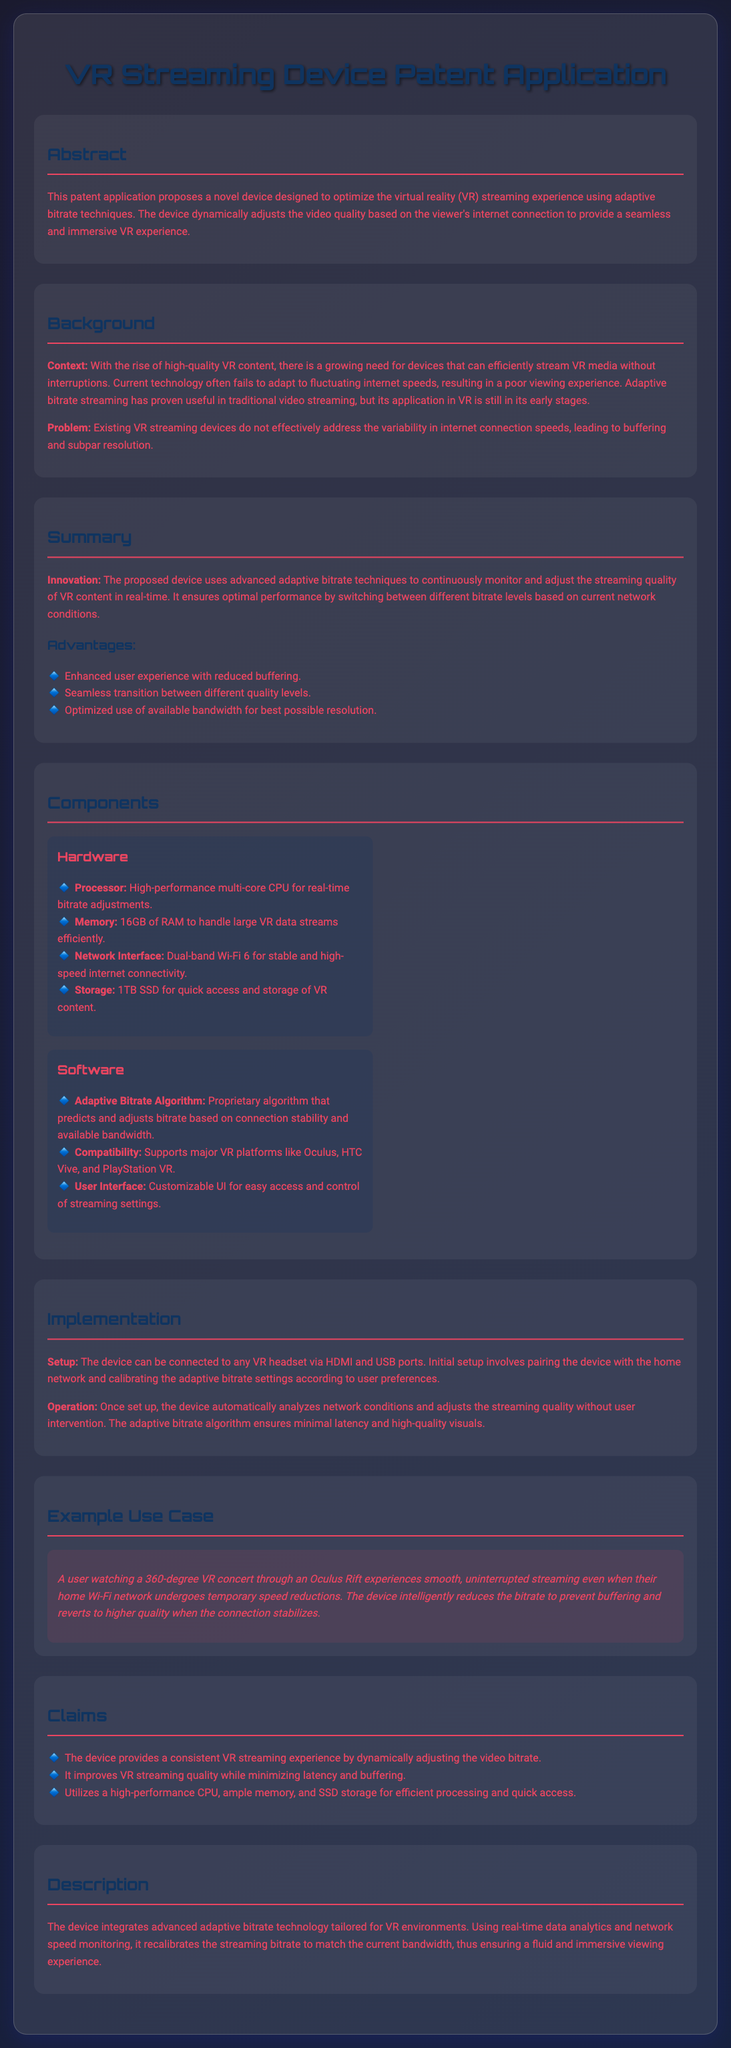What is the main purpose of the device? The main purpose of the device is to optimize the virtual reality (VR) streaming experience using adaptive bitrate techniques.
Answer: Optimize VR streaming experience What is the processor type mentioned? The document specifies a high-performance multi-core CPU for real-time bitrate adjustments.
Answer: High-performance multi-core CPU How much RAM does the device have? The device is stated to have 16GB of RAM to handle large VR data streams efficiently.
Answer: 16GB What is a major disadvantage of current VR streaming technology? The major disadvantage is that existing devices do not effectively address the variability in internet connection speeds.
Answer: Variability in internet connection speeds Which platforms does the software support? The software supports major VR platforms like Oculus, HTC Vive, and PlayStation VR.
Answer: Oculus, HTC Vive, PlayStation VR What happens when the home Wi-Fi network undergoes speed reductions? The device intelligently reduces the bitrate to prevent buffering.
Answer: Reduces the bitrate What is the total storage capacity of the device? The document mentions that the device has a storage capacity of 1TB SSD.
Answer: 1TB SSD How does the adaptive bitrate algorithm function? The algorithm predicts and adjusts bitrate based on connection stability and available bandwidth.
Answer: Predicts and adjusts bitrate What type of patent document is this? The document is a patent application for a device designed to enhance VR streaming.
Answer: Patent application 